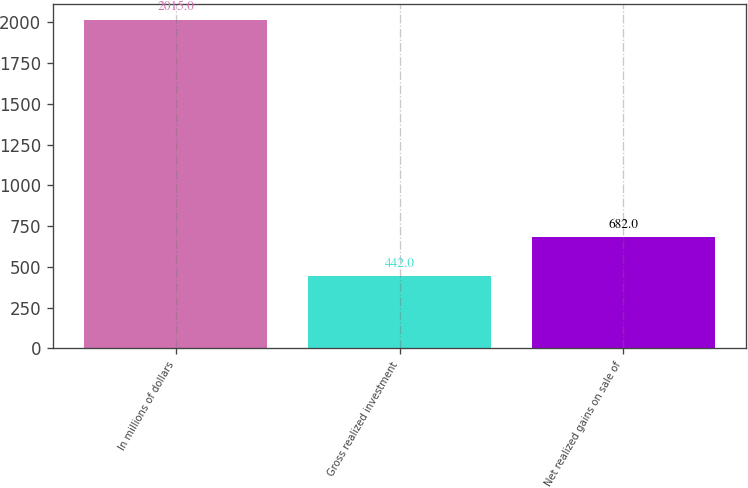Convert chart to OTSL. <chart><loc_0><loc_0><loc_500><loc_500><bar_chart><fcel>In millions of dollars<fcel>Gross realized investment<fcel>Net realized gains on sale of<nl><fcel>2015<fcel>442<fcel>682<nl></chart> 